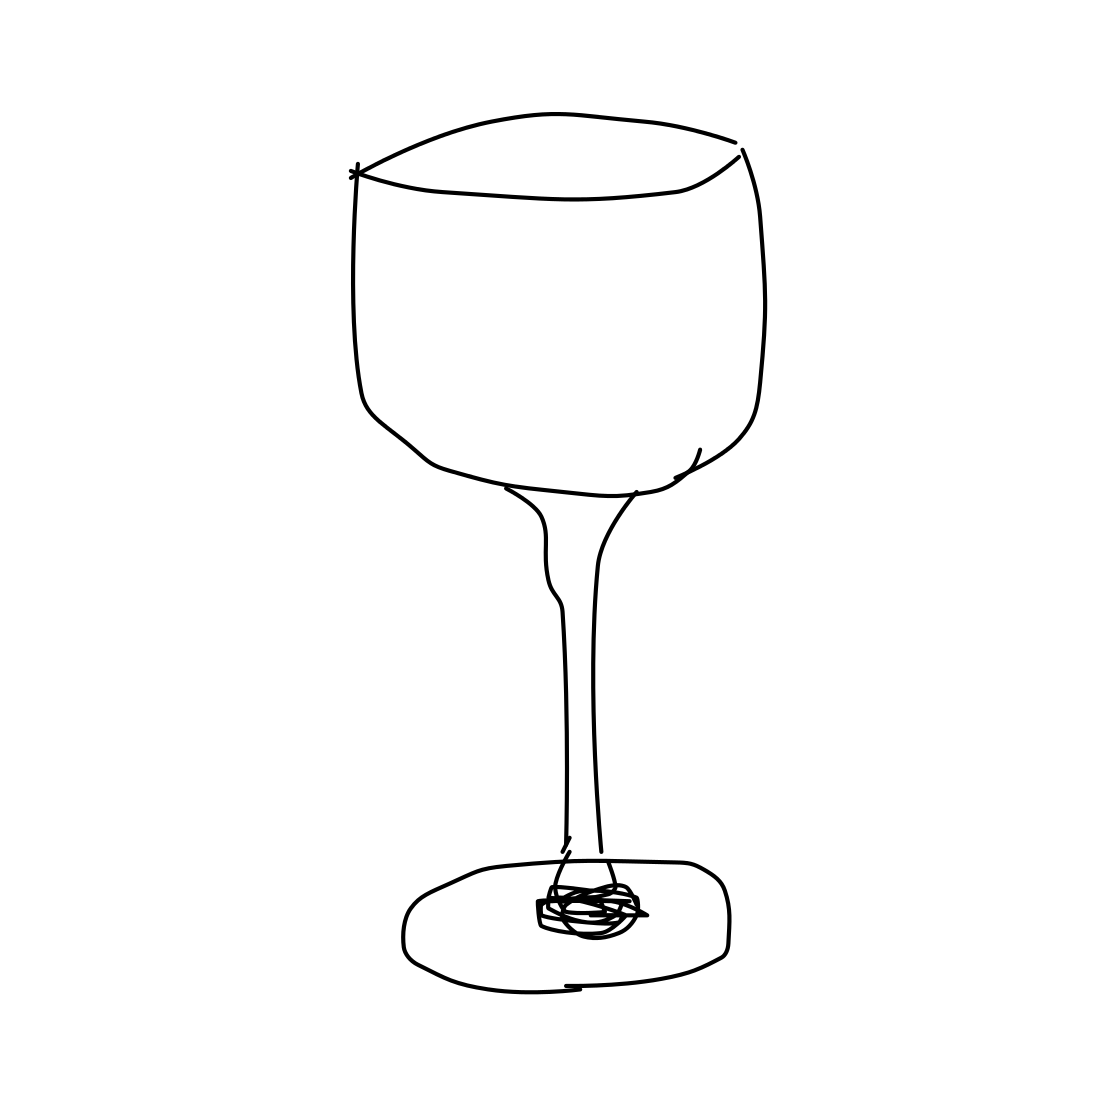Is this a wineglass in the image? Yes, the image depicts a wineglass, featuring a sizable bowl which is ideal for allowing wines to breathe. The simplistic line drawing captures the essence of the glass's design, which is commonly used to enhance the aroma and flavor experience of the wine. 